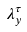Convert formula to latex. <formula><loc_0><loc_0><loc_500><loc_500>\lambda _ { y } ^ { \tau }</formula> 